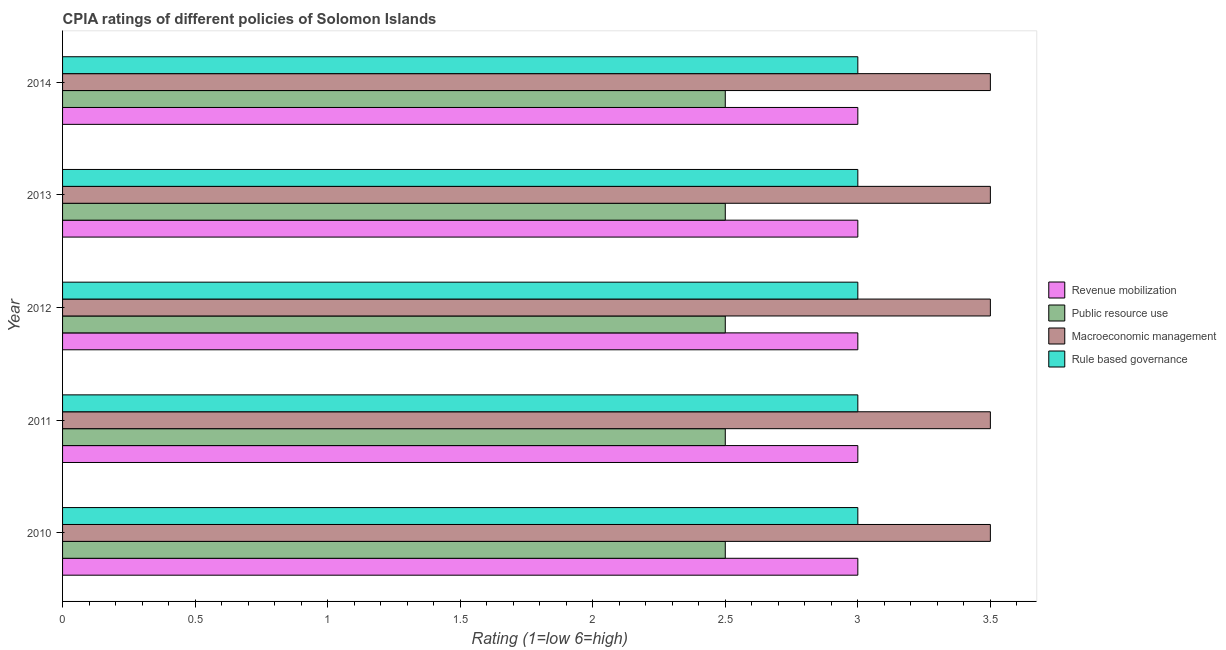In how many cases, is the number of bars for a given year not equal to the number of legend labels?
Your answer should be compact. 0. What is the cpia rating of rule based governance in 2012?
Keep it short and to the point. 3. Across all years, what is the minimum cpia rating of public resource use?
Your response must be concise. 2.5. What is the total cpia rating of macroeconomic management in the graph?
Make the answer very short. 17.5. What is the difference between the cpia rating of macroeconomic management in 2010 and that in 2014?
Give a very brief answer. 0. What is the difference between the cpia rating of public resource use in 2014 and the cpia rating of macroeconomic management in 2013?
Provide a succinct answer. -1. In how many years, is the cpia rating of macroeconomic management greater than 2 ?
Give a very brief answer. 5. What is the ratio of the cpia rating of macroeconomic management in 2010 to that in 2011?
Provide a succinct answer. 1. What is the difference between the highest and the second highest cpia rating of rule based governance?
Keep it short and to the point. 0. In how many years, is the cpia rating of macroeconomic management greater than the average cpia rating of macroeconomic management taken over all years?
Give a very brief answer. 0. Is the sum of the cpia rating of rule based governance in 2013 and 2014 greater than the maximum cpia rating of macroeconomic management across all years?
Make the answer very short. Yes. Is it the case that in every year, the sum of the cpia rating of rule based governance and cpia rating of revenue mobilization is greater than the sum of cpia rating of public resource use and cpia rating of macroeconomic management?
Provide a succinct answer. No. What does the 2nd bar from the top in 2011 represents?
Provide a succinct answer. Macroeconomic management. What does the 2nd bar from the bottom in 2010 represents?
Your response must be concise. Public resource use. Is it the case that in every year, the sum of the cpia rating of revenue mobilization and cpia rating of public resource use is greater than the cpia rating of macroeconomic management?
Give a very brief answer. Yes. What is the difference between two consecutive major ticks on the X-axis?
Offer a very short reply. 0.5. Are the values on the major ticks of X-axis written in scientific E-notation?
Offer a very short reply. No. Does the graph contain any zero values?
Give a very brief answer. No. Where does the legend appear in the graph?
Make the answer very short. Center right. How are the legend labels stacked?
Offer a very short reply. Vertical. What is the title of the graph?
Your answer should be very brief. CPIA ratings of different policies of Solomon Islands. Does "Australia" appear as one of the legend labels in the graph?
Your answer should be very brief. No. What is the label or title of the X-axis?
Ensure brevity in your answer.  Rating (1=low 6=high). What is the label or title of the Y-axis?
Offer a very short reply. Year. What is the Rating (1=low 6=high) of Macroeconomic management in 2010?
Provide a short and direct response. 3.5. What is the Rating (1=low 6=high) of Rule based governance in 2010?
Your answer should be compact. 3. What is the Rating (1=low 6=high) in Revenue mobilization in 2011?
Your response must be concise. 3. What is the Rating (1=low 6=high) in Macroeconomic management in 2011?
Your answer should be compact. 3.5. What is the Rating (1=low 6=high) of Rule based governance in 2012?
Make the answer very short. 3. What is the Rating (1=low 6=high) of Revenue mobilization in 2013?
Your answer should be very brief. 3. What is the Rating (1=low 6=high) of Public resource use in 2013?
Ensure brevity in your answer.  2.5. What is the Rating (1=low 6=high) in Macroeconomic management in 2013?
Your response must be concise. 3.5. What is the Rating (1=low 6=high) in Rule based governance in 2013?
Offer a terse response. 3. What is the Rating (1=low 6=high) in Macroeconomic management in 2014?
Your answer should be compact. 3.5. Across all years, what is the maximum Rating (1=low 6=high) in Public resource use?
Make the answer very short. 2.5. Across all years, what is the maximum Rating (1=low 6=high) in Rule based governance?
Keep it short and to the point. 3. Across all years, what is the minimum Rating (1=low 6=high) of Macroeconomic management?
Keep it short and to the point. 3.5. Across all years, what is the minimum Rating (1=low 6=high) of Rule based governance?
Provide a short and direct response. 3. What is the total Rating (1=low 6=high) of Revenue mobilization in the graph?
Offer a terse response. 15. What is the total Rating (1=low 6=high) in Public resource use in the graph?
Your answer should be compact. 12.5. What is the total Rating (1=low 6=high) of Macroeconomic management in the graph?
Give a very brief answer. 17.5. What is the total Rating (1=low 6=high) in Rule based governance in the graph?
Offer a very short reply. 15. What is the difference between the Rating (1=low 6=high) of Revenue mobilization in 2010 and that in 2011?
Give a very brief answer. 0. What is the difference between the Rating (1=low 6=high) in Public resource use in 2010 and that in 2011?
Ensure brevity in your answer.  0. What is the difference between the Rating (1=low 6=high) of Macroeconomic management in 2010 and that in 2011?
Keep it short and to the point. 0. What is the difference between the Rating (1=low 6=high) of Rule based governance in 2010 and that in 2011?
Give a very brief answer. 0. What is the difference between the Rating (1=low 6=high) in Revenue mobilization in 2010 and that in 2012?
Provide a succinct answer. 0. What is the difference between the Rating (1=low 6=high) of Public resource use in 2010 and that in 2012?
Your answer should be very brief. 0. What is the difference between the Rating (1=low 6=high) in Macroeconomic management in 2010 and that in 2012?
Your answer should be compact. 0. What is the difference between the Rating (1=low 6=high) of Rule based governance in 2010 and that in 2012?
Offer a terse response. 0. What is the difference between the Rating (1=low 6=high) in Macroeconomic management in 2010 and that in 2013?
Provide a short and direct response. 0. What is the difference between the Rating (1=low 6=high) of Rule based governance in 2010 and that in 2013?
Provide a short and direct response. 0. What is the difference between the Rating (1=low 6=high) in Revenue mobilization in 2010 and that in 2014?
Your answer should be compact. 0. What is the difference between the Rating (1=low 6=high) of Public resource use in 2010 and that in 2014?
Provide a succinct answer. 0. What is the difference between the Rating (1=low 6=high) of Macroeconomic management in 2011 and that in 2012?
Your answer should be compact. 0. What is the difference between the Rating (1=low 6=high) in Revenue mobilization in 2011 and that in 2013?
Provide a succinct answer. 0. What is the difference between the Rating (1=low 6=high) in Rule based governance in 2011 and that in 2013?
Give a very brief answer. 0. What is the difference between the Rating (1=low 6=high) of Public resource use in 2011 and that in 2014?
Your answer should be compact. 0. What is the difference between the Rating (1=low 6=high) of Public resource use in 2012 and that in 2013?
Give a very brief answer. 0. What is the difference between the Rating (1=low 6=high) in Revenue mobilization in 2012 and that in 2014?
Make the answer very short. 0. What is the difference between the Rating (1=low 6=high) of Revenue mobilization in 2013 and that in 2014?
Give a very brief answer. 0. What is the difference between the Rating (1=low 6=high) in Macroeconomic management in 2013 and that in 2014?
Ensure brevity in your answer.  0. What is the difference between the Rating (1=low 6=high) of Revenue mobilization in 2010 and the Rating (1=low 6=high) of Macroeconomic management in 2011?
Make the answer very short. -0.5. What is the difference between the Rating (1=low 6=high) of Revenue mobilization in 2010 and the Rating (1=low 6=high) of Public resource use in 2012?
Offer a very short reply. 0.5. What is the difference between the Rating (1=low 6=high) in Revenue mobilization in 2010 and the Rating (1=low 6=high) in Rule based governance in 2012?
Your response must be concise. 0. What is the difference between the Rating (1=low 6=high) in Public resource use in 2010 and the Rating (1=low 6=high) in Macroeconomic management in 2012?
Your answer should be very brief. -1. What is the difference between the Rating (1=low 6=high) of Macroeconomic management in 2010 and the Rating (1=low 6=high) of Rule based governance in 2012?
Offer a terse response. 0.5. What is the difference between the Rating (1=low 6=high) in Revenue mobilization in 2010 and the Rating (1=low 6=high) in Public resource use in 2013?
Give a very brief answer. 0.5. What is the difference between the Rating (1=low 6=high) in Revenue mobilization in 2010 and the Rating (1=low 6=high) in Macroeconomic management in 2013?
Provide a short and direct response. -0.5. What is the difference between the Rating (1=low 6=high) in Revenue mobilization in 2010 and the Rating (1=low 6=high) in Rule based governance in 2013?
Provide a short and direct response. 0. What is the difference between the Rating (1=low 6=high) in Public resource use in 2010 and the Rating (1=low 6=high) in Rule based governance in 2013?
Provide a succinct answer. -0.5. What is the difference between the Rating (1=low 6=high) in Macroeconomic management in 2010 and the Rating (1=low 6=high) in Rule based governance in 2013?
Give a very brief answer. 0.5. What is the difference between the Rating (1=low 6=high) in Revenue mobilization in 2010 and the Rating (1=low 6=high) in Public resource use in 2014?
Make the answer very short. 0.5. What is the difference between the Rating (1=low 6=high) of Revenue mobilization in 2010 and the Rating (1=low 6=high) of Macroeconomic management in 2014?
Ensure brevity in your answer.  -0.5. What is the difference between the Rating (1=low 6=high) of Revenue mobilization in 2010 and the Rating (1=low 6=high) of Rule based governance in 2014?
Offer a very short reply. 0. What is the difference between the Rating (1=low 6=high) in Public resource use in 2011 and the Rating (1=low 6=high) in Rule based governance in 2012?
Your answer should be compact. -0.5. What is the difference between the Rating (1=low 6=high) of Macroeconomic management in 2011 and the Rating (1=low 6=high) of Rule based governance in 2012?
Your answer should be compact. 0.5. What is the difference between the Rating (1=low 6=high) in Revenue mobilization in 2011 and the Rating (1=low 6=high) in Rule based governance in 2013?
Offer a very short reply. 0. What is the difference between the Rating (1=low 6=high) in Public resource use in 2011 and the Rating (1=low 6=high) in Macroeconomic management in 2013?
Your answer should be compact. -1. What is the difference between the Rating (1=low 6=high) in Public resource use in 2011 and the Rating (1=low 6=high) in Rule based governance in 2013?
Provide a short and direct response. -0.5. What is the difference between the Rating (1=low 6=high) in Macroeconomic management in 2011 and the Rating (1=low 6=high) in Rule based governance in 2013?
Provide a succinct answer. 0.5. What is the difference between the Rating (1=low 6=high) of Revenue mobilization in 2011 and the Rating (1=low 6=high) of Public resource use in 2014?
Your answer should be very brief. 0.5. What is the difference between the Rating (1=low 6=high) in Revenue mobilization in 2011 and the Rating (1=low 6=high) in Macroeconomic management in 2014?
Make the answer very short. -0.5. What is the difference between the Rating (1=low 6=high) of Public resource use in 2011 and the Rating (1=low 6=high) of Rule based governance in 2014?
Provide a short and direct response. -0.5. What is the difference between the Rating (1=low 6=high) of Macroeconomic management in 2011 and the Rating (1=low 6=high) of Rule based governance in 2014?
Give a very brief answer. 0.5. What is the difference between the Rating (1=low 6=high) in Revenue mobilization in 2012 and the Rating (1=low 6=high) in Public resource use in 2013?
Your response must be concise. 0.5. What is the difference between the Rating (1=low 6=high) in Revenue mobilization in 2012 and the Rating (1=low 6=high) in Rule based governance in 2013?
Your answer should be very brief. 0. What is the difference between the Rating (1=low 6=high) in Public resource use in 2012 and the Rating (1=low 6=high) in Rule based governance in 2013?
Offer a terse response. -0.5. What is the difference between the Rating (1=low 6=high) of Revenue mobilization in 2012 and the Rating (1=low 6=high) of Macroeconomic management in 2014?
Provide a short and direct response. -0.5. What is the difference between the Rating (1=low 6=high) in Public resource use in 2012 and the Rating (1=low 6=high) in Macroeconomic management in 2014?
Your answer should be compact. -1. What is the difference between the Rating (1=low 6=high) in Public resource use in 2012 and the Rating (1=low 6=high) in Rule based governance in 2014?
Your answer should be compact. -0.5. What is the difference between the Rating (1=low 6=high) in Macroeconomic management in 2012 and the Rating (1=low 6=high) in Rule based governance in 2014?
Keep it short and to the point. 0.5. What is the difference between the Rating (1=low 6=high) in Revenue mobilization in 2013 and the Rating (1=low 6=high) in Macroeconomic management in 2014?
Provide a short and direct response. -0.5. What is the difference between the Rating (1=low 6=high) in Revenue mobilization in 2013 and the Rating (1=low 6=high) in Rule based governance in 2014?
Make the answer very short. 0. What is the difference between the Rating (1=low 6=high) of Public resource use in 2013 and the Rating (1=low 6=high) of Macroeconomic management in 2014?
Provide a short and direct response. -1. What is the average Rating (1=low 6=high) in Macroeconomic management per year?
Provide a short and direct response. 3.5. What is the average Rating (1=low 6=high) of Rule based governance per year?
Provide a succinct answer. 3. In the year 2010, what is the difference between the Rating (1=low 6=high) of Revenue mobilization and Rating (1=low 6=high) of Public resource use?
Offer a very short reply. 0.5. In the year 2010, what is the difference between the Rating (1=low 6=high) in Revenue mobilization and Rating (1=low 6=high) in Macroeconomic management?
Offer a terse response. -0.5. In the year 2010, what is the difference between the Rating (1=low 6=high) in Public resource use and Rating (1=low 6=high) in Rule based governance?
Make the answer very short. -0.5. In the year 2010, what is the difference between the Rating (1=low 6=high) of Macroeconomic management and Rating (1=low 6=high) of Rule based governance?
Ensure brevity in your answer.  0.5. In the year 2011, what is the difference between the Rating (1=low 6=high) in Revenue mobilization and Rating (1=low 6=high) in Public resource use?
Your answer should be compact. 0.5. In the year 2011, what is the difference between the Rating (1=low 6=high) in Macroeconomic management and Rating (1=low 6=high) in Rule based governance?
Your answer should be compact. 0.5. In the year 2012, what is the difference between the Rating (1=low 6=high) of Revenue mobilization and Rating (1=low 6=high) of Public resource use?
Give a very brief answer. 0.5. In the year 2012, what is the difference between the Rating (1=low 6=high) in Revenue mobilization and Rating (1=low 6=high) in Macroeconomic management?
Provide a succinct answer. -0.5. In the year 2013, what is the difference between the Rating (1=low 6=high) in Revenue mobilization and Rating (1=low 6=high) in Macroeconomic management?
Offer a very short reply. -0.5. In the year 2013, what is the difference between the Rating (1=low 6=high) of Public resource use and Rating (1=low 6=high) of Rule based governance?
Your answer should be compact. -0.5. In the year 2013, what is the difference between the Rating (1=low 6=high) of Macroeconomic management and Rating (1=low 6=high) of Rule based governance?
Your response must be concise. 0.5. In the year 2014, what is the difference between the Rating (1=low 6=high) in Revenue mobilization and Rating (1=low 6=high) in Macroeconomic management?
Give a very brief answer. -0.5. In the year 2014, what is the difference between the Rating (1=low 6=high) in Revenue mobilization and Rating (1=low 6=high) in Rule based governance?
Provide a short and direct response. 0. In the year 2014, what is the difference between the Rating (1=low 6=high) in Public resource use and Rating (1=low 6=high) in Rule based governance?
Your answer should be very brief. -0.5. In the year 2014, what is the difference between the Rating (1=low 6=high) of Macroeconomic management and Rating (1=low 6=high) of Rule based governance?
Give a very brief answer. 0.5. What is the ratio of the Rating (1=low 6=high) in Revenue mobilization in 2010 to that in 2011?
Offer a very short reply. 1. What is the ratio of the Rating (1=low 6=high) of Rule based governance in 2010 to that in 2011?
Provide a short and direct response. 1. What is the ratio of the Rating (1=low 6=high) of Public resource use in 2010 to that in 2012?
Provide a short and direct response. 1. What is the ratio of the Rating (1=low 6=high) in Macroeconomic management in 2010 to that in 2013?
Offer a terse response. 1. What is the ratio of the Rating (1=low 6=high) in Public resource use in 2010 to that in 2014?
Provide a succinct answer. 1. What is the ratio of the Rating (1=low 6=high) of Macroeconomic management in 2010 to that in 2014?
Provide a short and direct response. 1. What is the ratio of the Rating (1=low 6=high) in Macroeconomic management in 2011 to that in 2012?
Provide a short and direct response. 1. What is the ratio of the Rating (1=low 6=high) of Revenue mobilization in 2011 to that in 2013?
Your answer should be compact. 1. What is the ratio of the Rating (1=low 6=high) of Public resource use in 2011 to that in 2013?
Your response must be concise. 1. What is the ratio of the Rating (1=low 6=high) of Macroeconomic management in 2011 to that in 2013?
Your answer should be compact. 1. What is the ratio of the Rating (1=low 6=high) in Public resource use in 2011 to that in 2014?
Provide a short and direct response. 1. What is the ratio of the Rating (1=low 6=high) of Macroeconomic management in 2011 to that in 2014?
Offer a terse response. 1. What is the ratio of the Rating (1=low 6=high) in Rule based governance in 2011 to that in 2014?
Make the answer very short. 1. What is the ratio of the Rating (1=low 6=high) of Revenue mobilization in 2012 to that in 2013?
Ensure brevity in your answer.  1. What is the ratio of the Rating (1=low 6=high) in Rule based governance in 2012 to that in 2014?
Your response must be concise. 1. What is the ratio of the Rating (1=low 6=high) in Revenue mobilization in 2013 to that in 2014?
Ensure brevity in your answer.  1. What is the ratio of the Rating (1=low 6=high) in Public resource use in 2013 to that in 2014?
Offer a very short reply. 1. What is the difference between the highest and the second highest Rating (1=low 6=high) of Public resource use?
Your response must be concise. 0. What is the difference between the highest and the second highest Rating (1=low 6=high) of Macroeconomic management?
Offer a terse response. 0. What is the difference between the highest and the second highest Rating (1=low 6=high) in Rule based governance?
Your response must be concise. 0. What is the difference between the highest and the lowest Rating (1=low 6=high) in Rule based governance?
Ensure brevity in your answer.  0. 